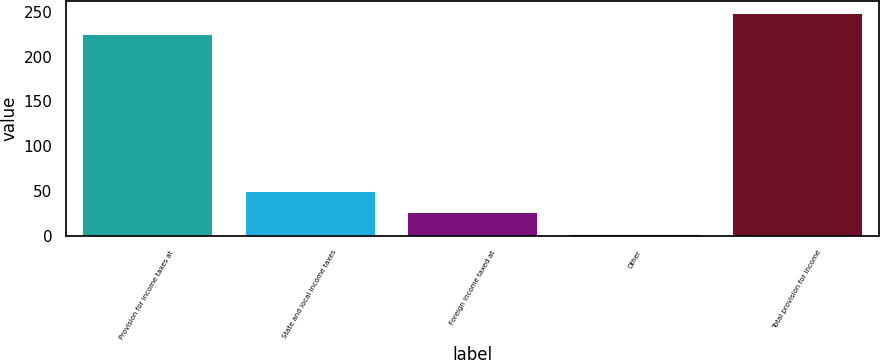<chart> <loc_0><loc_0><loc_500><loc_500><bar_chart><fcel>Provision for income taxes at<fcel>State and local income taxes<fcel>Foreign income taxed at<fcel>Other<fcel>Total provision for income<nl><fcel>225.1<fcel>50.72<fcel>26.76<fcel>2.8<fcel>249.06<nl></chart> 